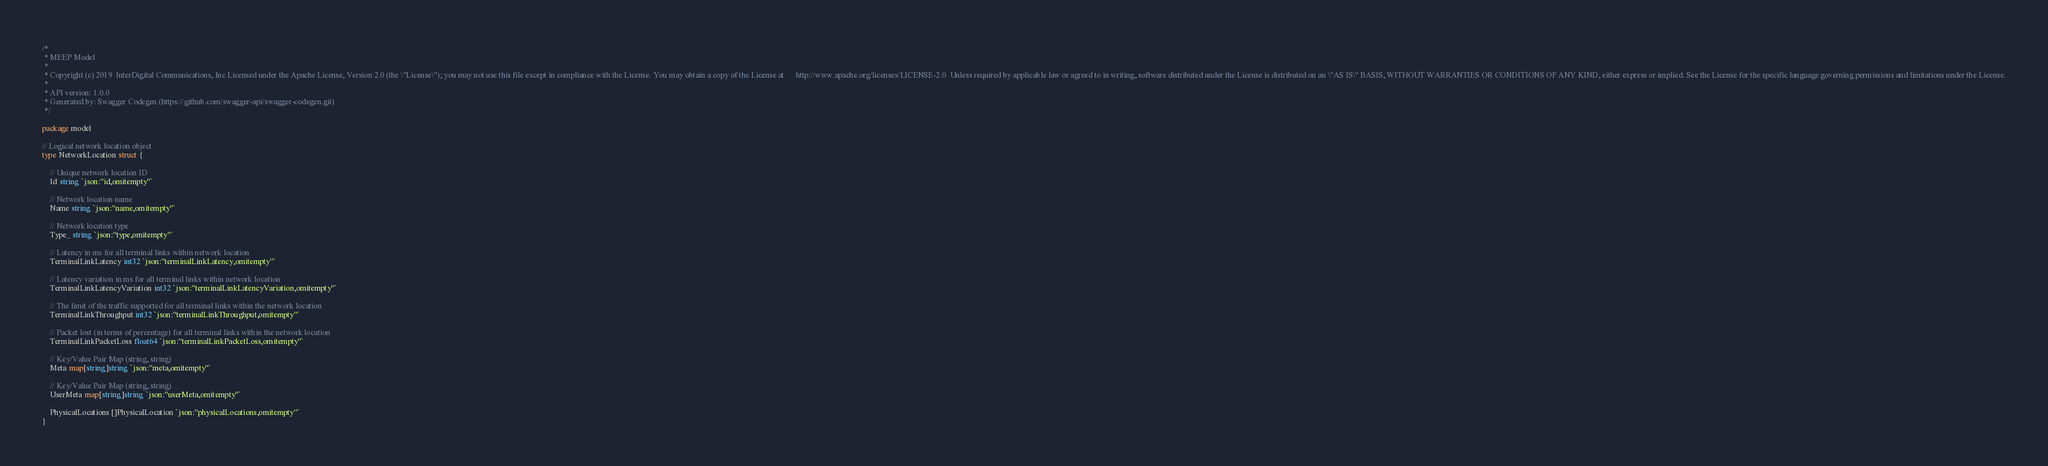<code> <loc_0><loc_0><loc_500><loc_500><_Go_>/*
 * MEEP Model
 *
 * Copyright (c) 2019  InterDigital Communications, Inc Licensed under the Apache License, Version 2.0 (the \"License\"); you may not use this file except in compliance with the License. You may obtain a copy of the License at      http://www.apache.org/licenses/LICENSE-2.0  Unless required by applicable law or agreed to in writing, software distributed under the License is distributed on an \"AS IS\" BASIS, WITHOUT WARRANTIES OR CONDITIONS OF ANY KIND, either express or implied. See the License for the specific language governing permissions and limitations under the License.
 *
 * API version: 1.0.0
 * Generated by: Swagger Codegen (https://github.com/swagger-api/swagger-codegen.git)
 */

package model

// Logical network location object
type NetworkLocation struct {

	// Unique network location ID
	Id string `json:"id,omitempty"`

	// Network location name
	Name string `json:"name,omitempty"`

	// Network location type
	Type_ string `json:"type,omitempty"`

	// Latency in ms for all terminal links within network location
	TerminalLinkLatency int32 `json:"terminalLinkLatency,omitempty"`

	// Latency variation in ms for all terminal links within network location
	TerminalLinkLatencyVariation int32 `json:"terminalLinkLatencyVariation,omitempty"`

	// The limit of the traffic supported for all terminal links within the network location
	TerminalLinkThroughput int32 `json:"terminalLinkThroughput,omitempty"`

	// Packet lost (in terms of percentage) for all terminal links within the network location
	TerminalLinkPacketLoss float64 `json:"terminalLinkPacketLoss,omitempty"`

	// Key/Value Pair Map (string, string)
	Meta map[string]string `json:"meta,omitempty"`

	// Key/Value Pair Map (string, string)
	UserMeta map[string]string `json:"userMeta,omitempty"`

	PhysicalLocations []PhysicalLocation `json:"physicalLocations,omitempty"`
}
</code> 